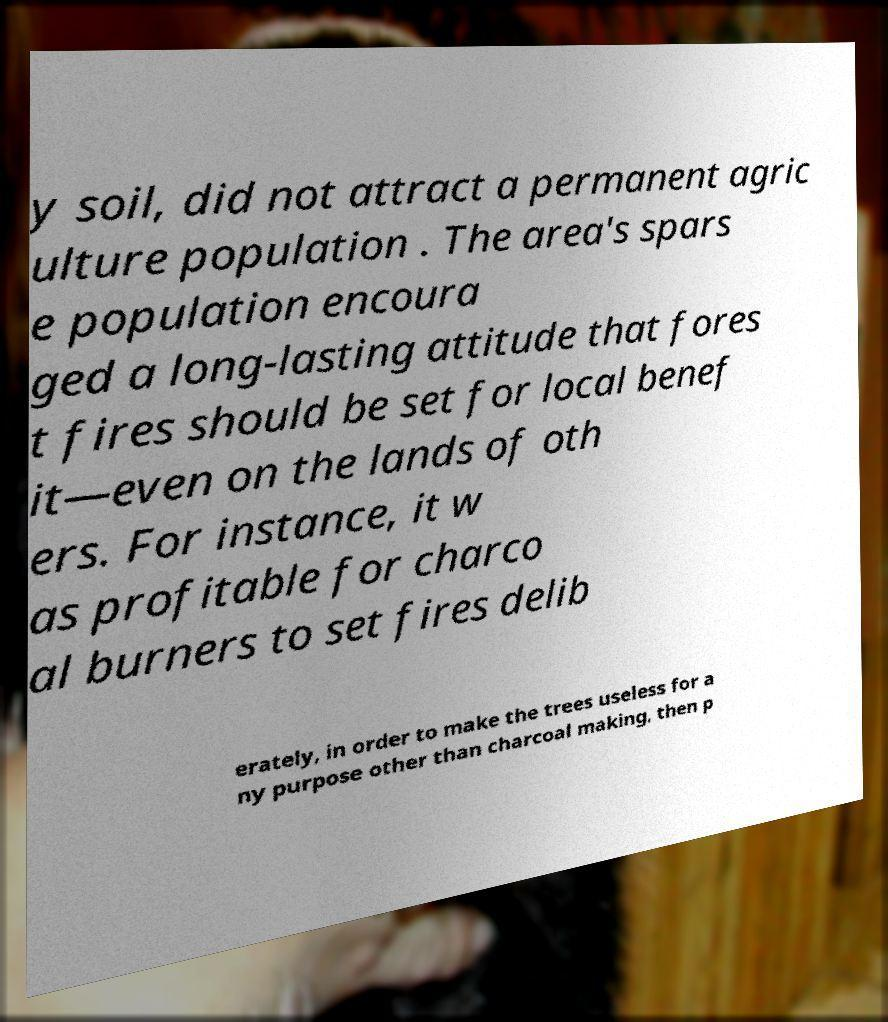Can you read and provide the text displayed in the image?This photo seems to have some interesting text. Can you extract and type it out for me? y soil, did not attract a permanent agric ulture population . The area's spars e population encoura ged a long-lasting attitude that fores t fires should be set for local benef it—even on the lands of oth ers. For instance, it w as profitable for charco al burners to set fires delib erately, in order to make the trees useless for a ny purpose other than charcoal making, then p 